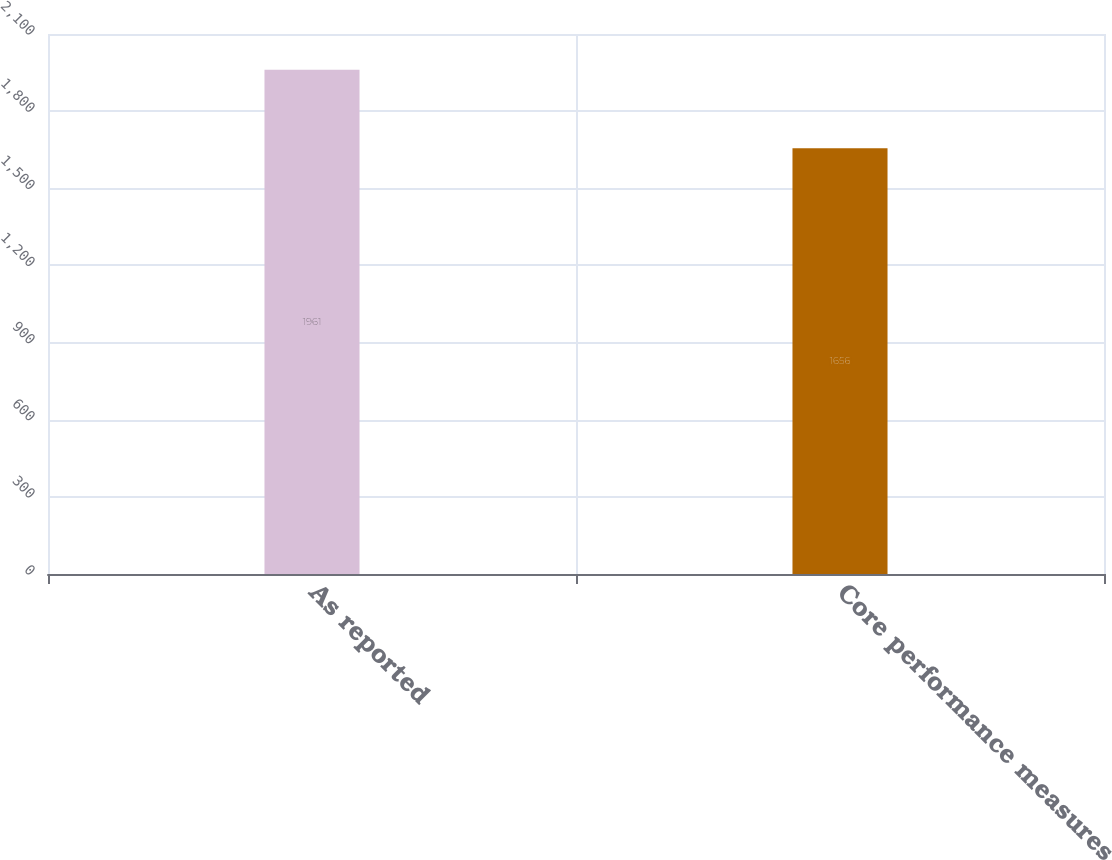<chart> <loc_0><loc_0><loc_500><loc_500><bar_chart><fcel>As reported<fcel>Core performance measures<nl><fcel>1961<fcel>1656<nl></chart> 